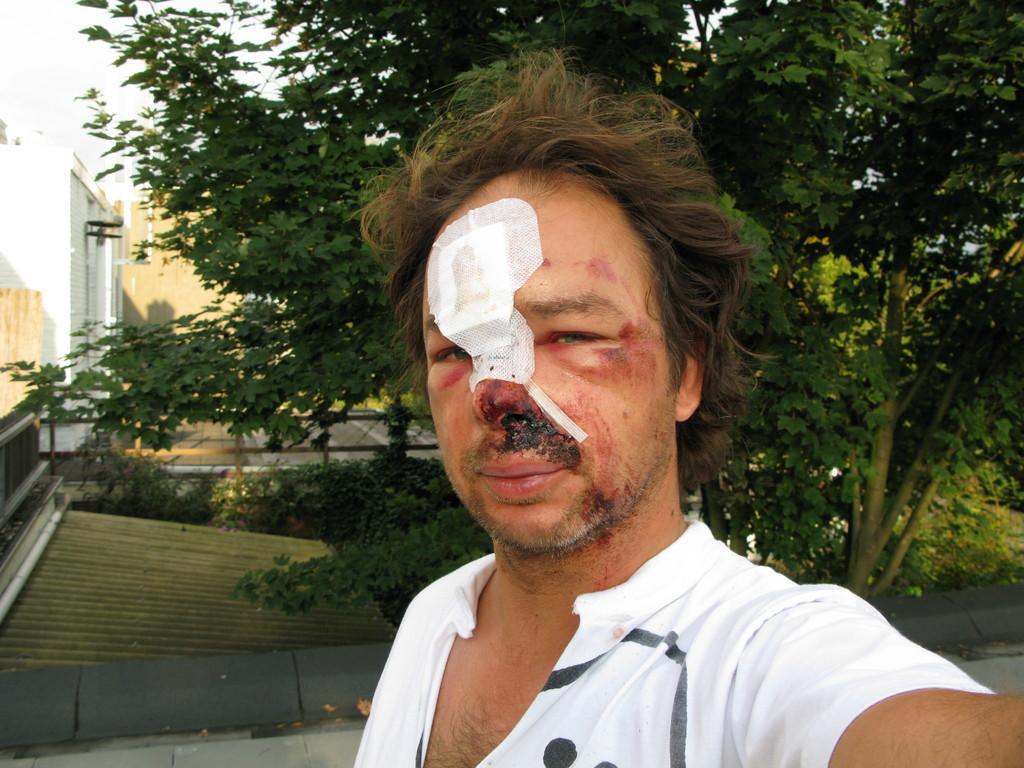Can you describe this image briefly? In the middle of the image there is a man with white t-shirt and on his face there is a bandage and also there are many wounds. Behind him there are many trees and also to the left side of the image there is a white buildings with walls. 